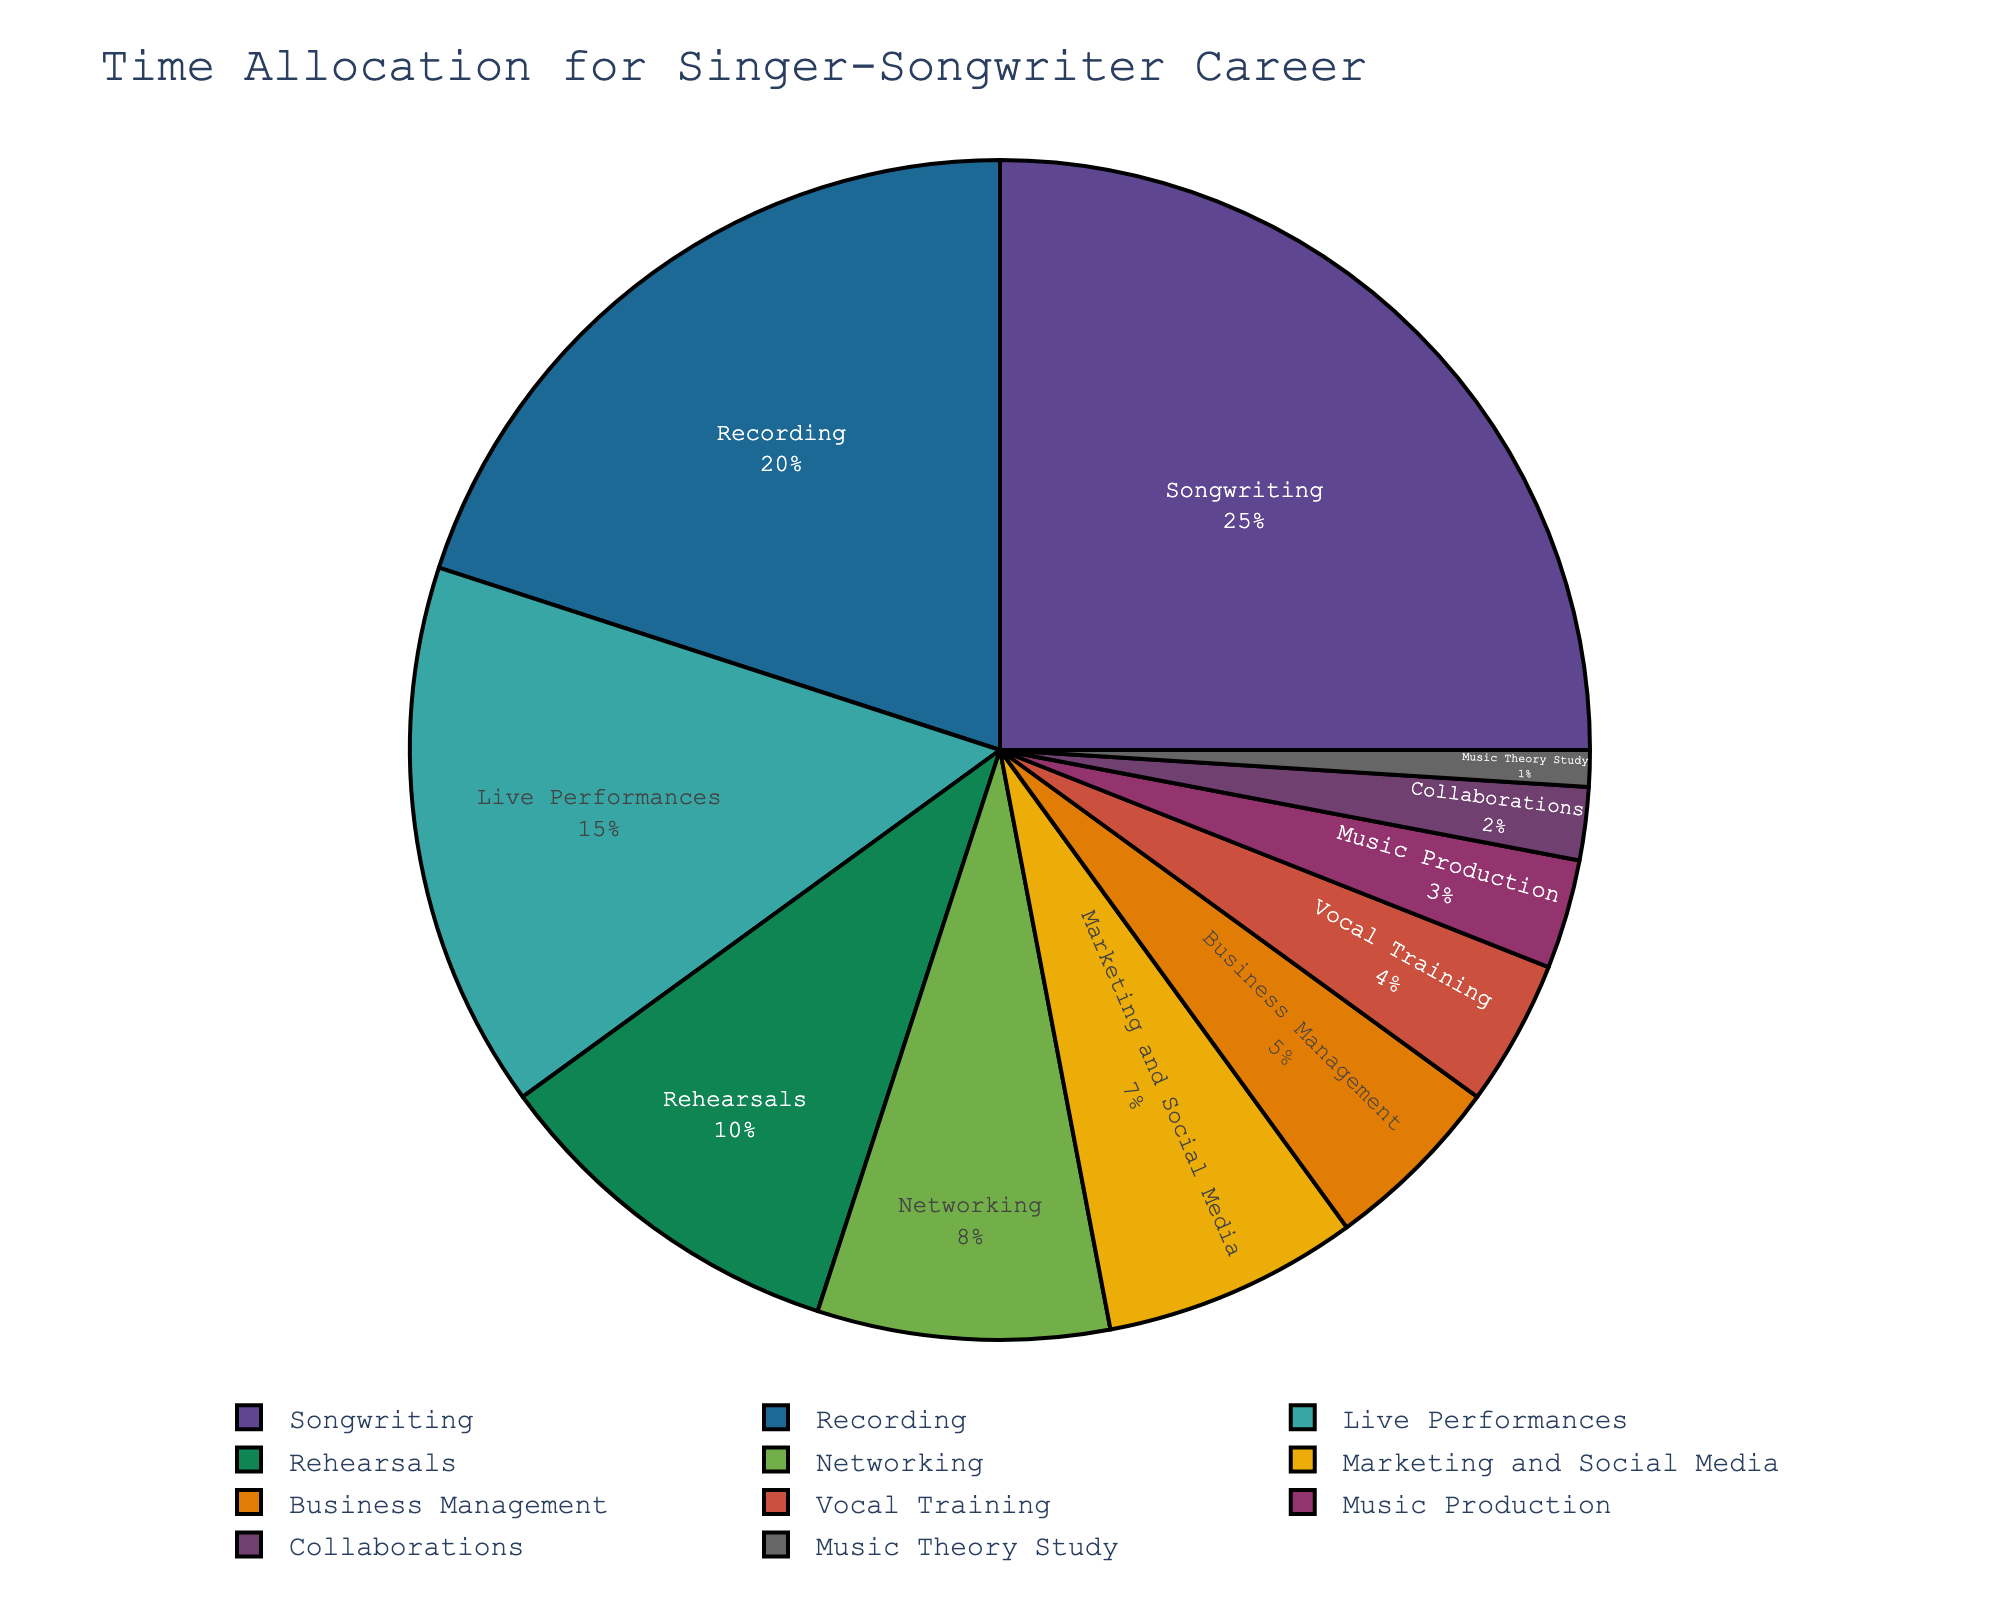What activity takes up the largest portion of time? The slice with the largest percentage represents the most time-consuming activity, which is labeled as "Songwriting" with 25%.
Answer: Songwriting Which two activities together make up 30% of the time allocation? Adding the percentages of "Recording" (20%) and "Rehearsals" (10%) sums up to 30%.
Answer: Recording and Rehearsals What is the combined percentage of Networking and Marketing and Social Media? The slice labeled "Networking" shows 8%, and "Marketing and Social Media" shows 7%. Adding these together gives 8% + 7% = 15%.
Answer: 15% How does the time spent on Live Performances compare with Business Management? The slice for "Live Performances" is labeled with 15%, and "Business Management" shows 5%. Live Performances take up a larger portion of time.
Answer: Live Performances take up more time Which activity requires the least amount of time? The smallest slice in the pie chart is labeled "Music Theory Study" with 1%.
Answer: Music Theory Study Are there any activities that require the same amount of time? By visually inspecting the sizes and percentages of the slices, no activities share the same exact percentage value in the given data.
Answer: No What percentage of time is spent on activities related to creating music (Songwriting, Recording, Music Production)? Adding the percentages of "Songwriting" (25%), "Recording" (20%), and "Music Production" (3%) gives 25% + 20% + 3% = 48%.
Answer: 48% Is more time allocated to Rehearsals or Vocational Training? Comparing the percentages, Rehearsals (10%) versus Vocational Training (4%), Rehearsals have a higher percentage.
Answer: Rehearsals What percentage of time is spent on activities not directly related to music creation (Networking, Marketing and Social Media, Business Management, Vocal Training, Collaborations, Music Theory Study)? Adding these percentages, Networking (8%), Marketing and Social Media (7%), Business Management (5%), Vocal Training (4%), Collaborations (2%), Music Theory Study (1%) gives 8% + 7% + 5% + 4% + 2% + 1% = 27%.
Answer: 27% What is the median value of the percentages shown in the pie chart? The ordered percentages are 1, 2, 3, 4, 5, 7, 8, 10, 15, 20, 25. The middle value in this ordered set is the 7th value, which is "8%".
Answer: 8% 